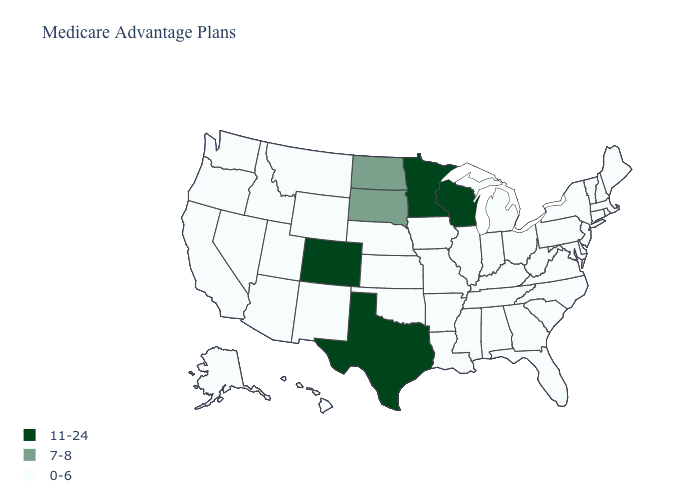Does the map have missing data?
Concise answer only. No. What is the value of Utah?
Concise answer only. 0-6. What is the highest value in the USA?
Give a very brief answer. 11-24. Does Mississippi have the lowest value in the South?
Concise answer only. Yes. What is the value of New Mexico?
Be succinct. 0-6. What is the value of Georgia?
Concise answer only. 0-6. Does Missouri have a lower value than Texas?
Short answer required. Yes. What is the value of Pennsylvania?
Concise answer only. 0-6. Does the map have missing data?
Keep it brief. No. Among the states that border Arizona , which have the lowest value?
Short answer required. California, New Mexico, Nevada, Utah. What is the lowest value in the USA?
Concise answer only. 0-6. Which states have the lowest value in the USA?
Give a very brief answer. Alaska, Alabama, Arkansas, Arizona, California, Connecticut, Delaware, Florida, Georgia, Hawaii, Iowa, Idaho, Illinois, Indiana, Kansas, Kentucky, Louisiana, Massachusetts, Maryland, Maine, Michigan, Missouri, Mississippi, Montana, North Carolina, Nebraska, New Hampshire, New Jersey, New Mexico, Nevada, New York, Ohio, Oklahoma, Oregon, Pennsylvania, Rhode Island, South Carolina, Tennessee, Utah, Virginia, Vermont, Washington, West Virginia, Wyoming. Does the first symbol in the legend represent the smallest category?
Quick response, please. No. Name the states that have a value in the range 11-24?
Be succinct. Colorado, Minnesota, Texas, Wisconsin. Is the legend a continuous bar?
Be succinct. No. 